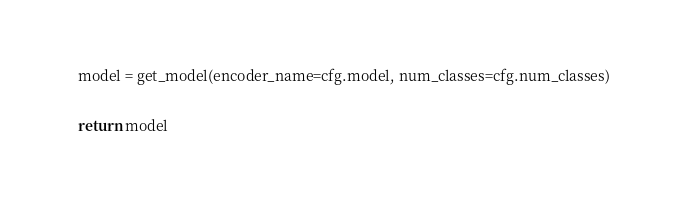<code> <loc_0><loc_0><loc_500><loc_500><_Python_>    model = get_model(encoder_name=cfg.model, num_classes=cfg.num_classes)

    return model
</code> 